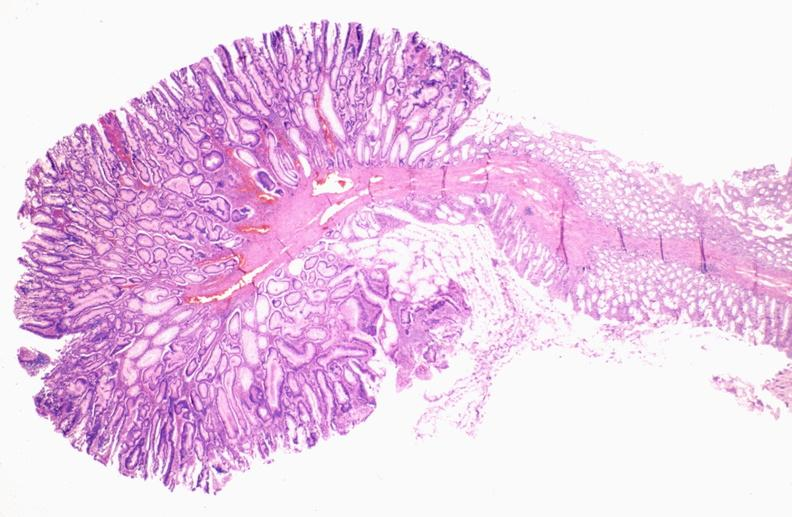what does this image show?
Answer the question using a single word or phrase. Colon 